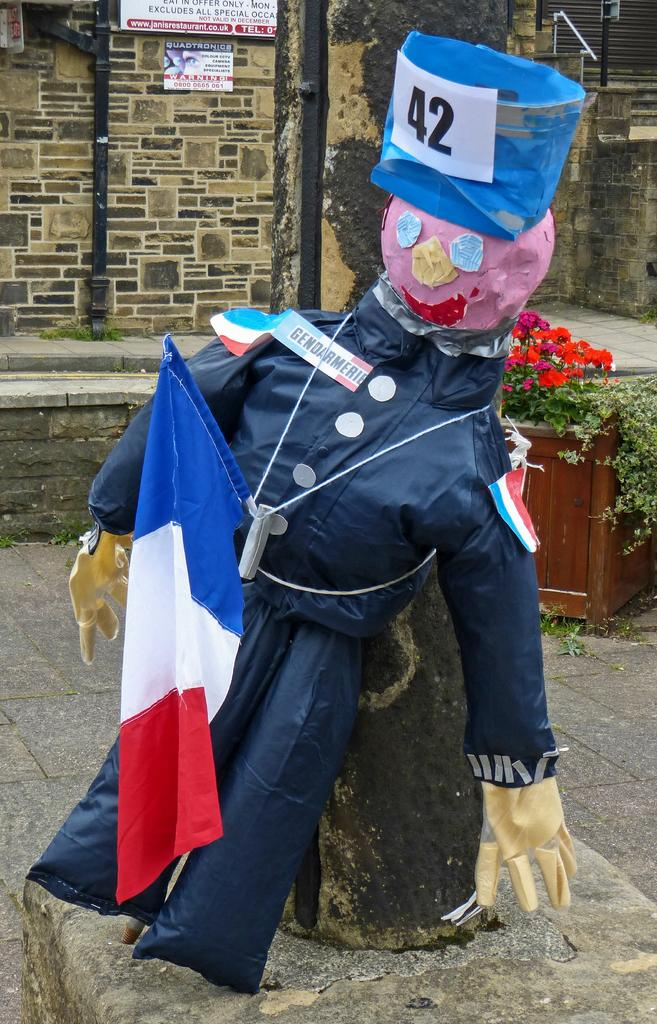What is the main subject of the image? There is a scarecrow in the image. What else can be seen in the image besides the scarecrow? There is a flag in the image. What can be seen in the background of the image? There are plants, flowers, and metal rods in the background of the image. What is on the wall in the image? There is a hoarding on a wall in the image. What type of pot is on the scarecrow's head in the image? There is no pot on the scarecrow's head in the image. What color is the wristband on the scarecrow's wrist in the image? There is no wristband on the scarecrow's wrist in the image. 